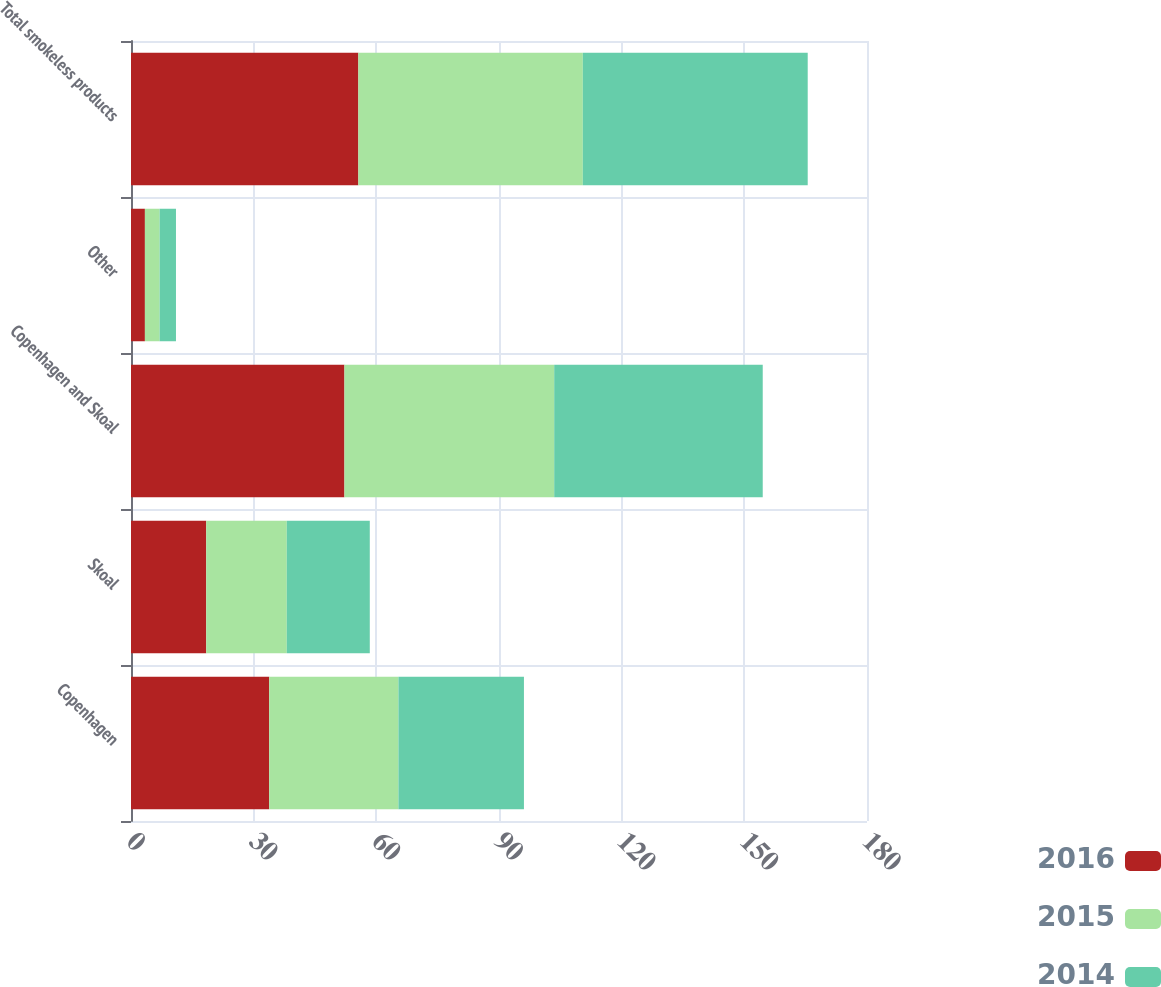Convert chart to OTSL. <chart><loc_0><loc_0><loc_500><loc_500><stacked_bar_chart><ecel><fcel>Copenhagen<fcel>Skoal<fcel>Copenhagen and Skoal<fcel>Other<fcel>Total smokeless products<nl><fcel>2016<fcel>33.8<fcel>18.4<fcel>52.2<fcel>3.4<fcel>55.6<nl><fcel>2015<fcel>31.6<fcel>19.7<fcel>51.3<fcel>3.6<fcel>54.9<nl><fcel>2014<fcel>30.7<fcel>20.3<fcel>51<fcel>4<fcel>55<nl></chart> 